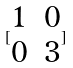<formula> <loc_0><loc_0><loc_500><loc_500>[ \begin{matrix} 1 & 0 \\ 0 & 3 \end{matrix} ]</formula> 